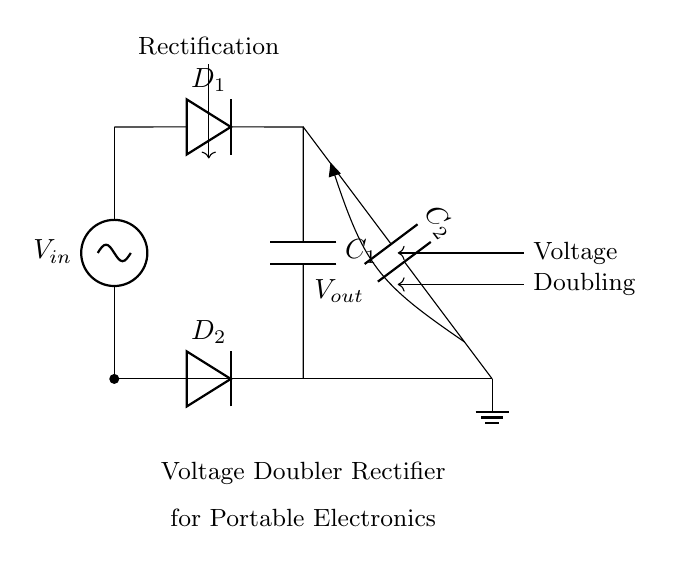What is the input voltage of the circuit? The input voltage, labeled as V_in in the circuit, is the voltage source provided to the rectifier circuit. It is the first point of reference visually marked on the circuit diagram.
Answer: V_in How many capacitors are there in the circuit? The circuit diagram shows two capacitors, C_1 and C_2, which are identifiable symbols. By counting them, we conclude that there are two capacitors present.
Answer: 2 What is the function of D_1 in this circuit? D_1 is a diode responsible for allowing current to flow in one direction, specifically during the positive half-cycle of the AC input, which is essential for rectification.
Answer: Rectification What is the role of C_2 in the voltage doubling process? C_2 stores electrical energy after rectification by D_1 and then discharges its stored energy to deliver a doubled output voltage. This storage is crucial for the voltage-doubling effect in the circuit.
Answer: Energy storage What is the output voltage of the circuit compared to the input voltage? The circuit is designed as a voltage doubler rectifier; thus, the output voltage V_out is theoretically twice the input voltage V_in, taking into account ideal conditions without losses.
Answer: 2 * V_in Which component is responsible for allowing current to flow in the opposite direction during the negative cycle? D_2 is the second diode used in this circuit, and it allows current to pass during the negative half-cycle of the AC input, completing the rectification process for both halves of the input waveform.
Answer: D_2 What type of rectifier configuration is used in this circuit? This circuit employs a voltage doubler configuration, which is a specific type of rectifier setup designed to increase the output voltage by using capacitors and diodes effectively for the intended application.
Answer: Voltage doubler 